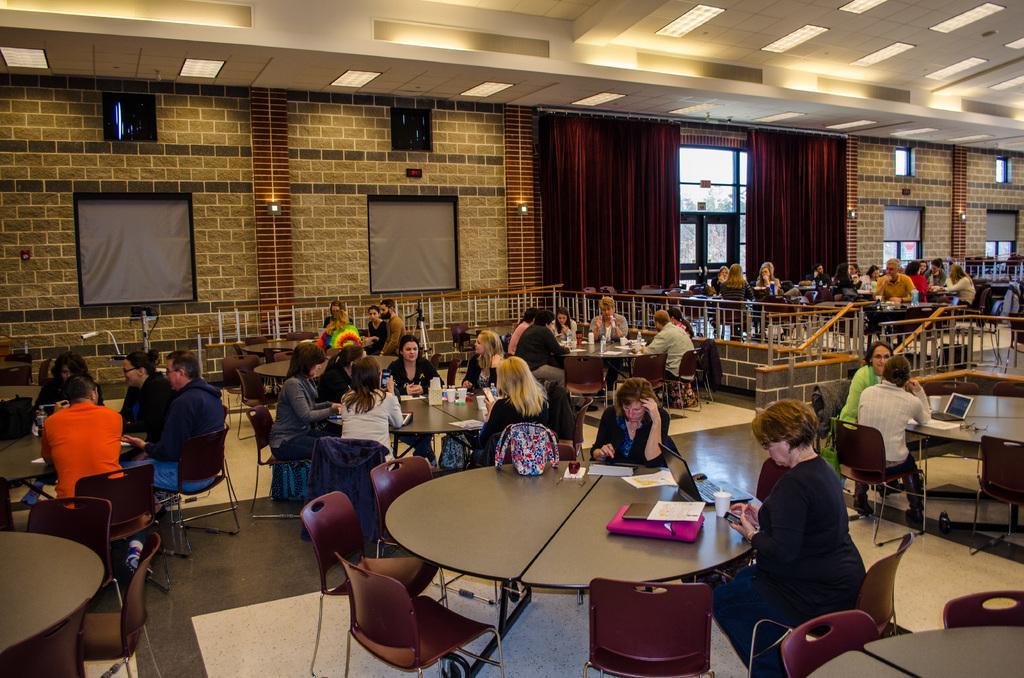Can you describe this image briefly? In this image I can see number of people are sitting on chairs. I can also see number of tables and two curtains over here. 